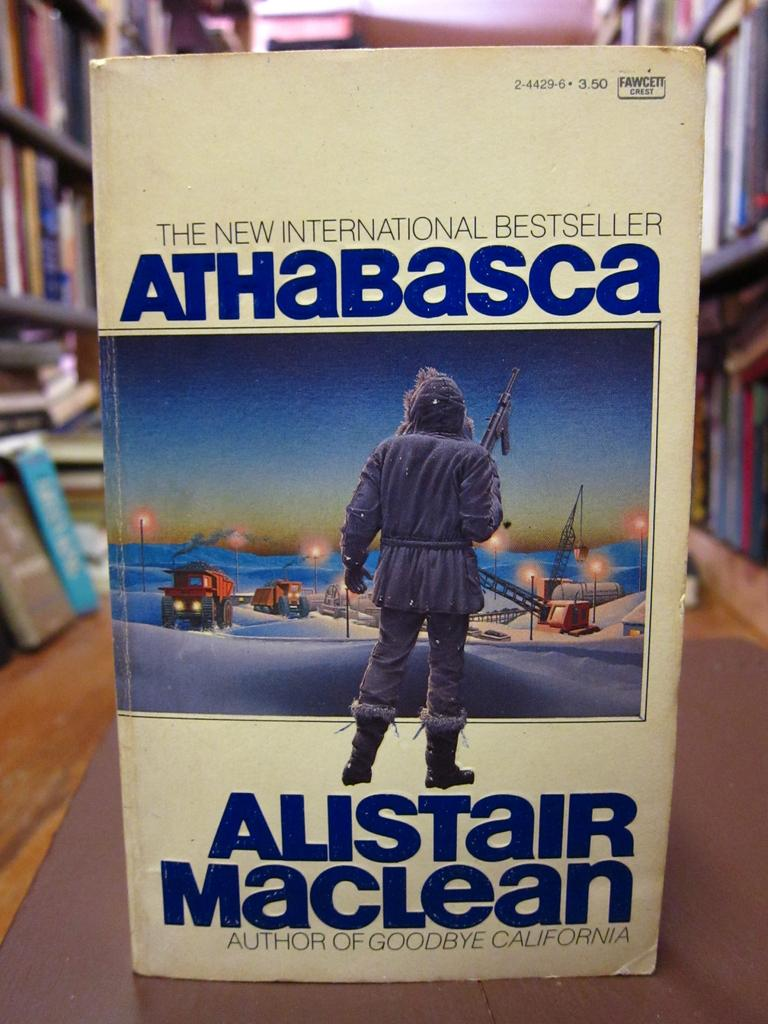Provide a one-sentence caption for the provided image. A book with a cream cover reading The New International Bestseller. 